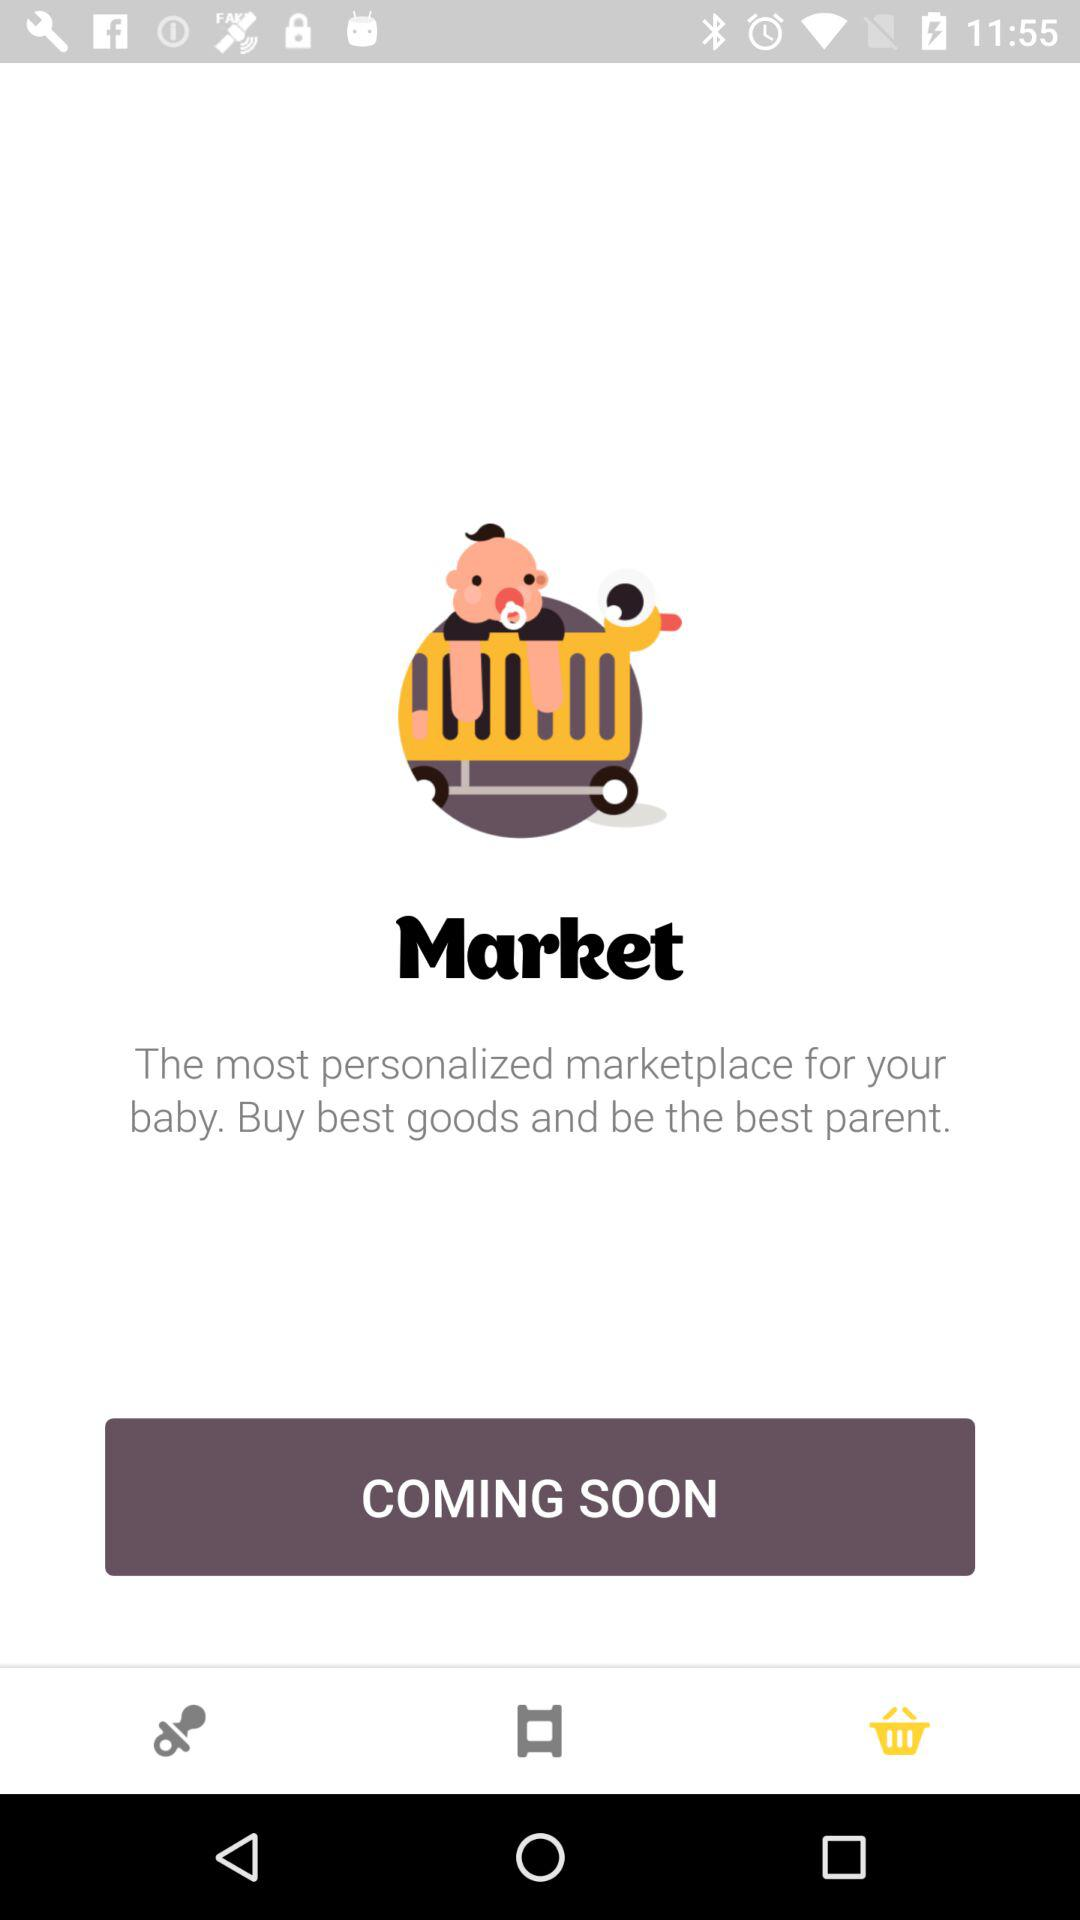What is the application name? The application name is "Market". 